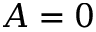Convert formula to latex. <formula><loc_0><loc_0><loc_500><loc_500>A = 0</formula> 